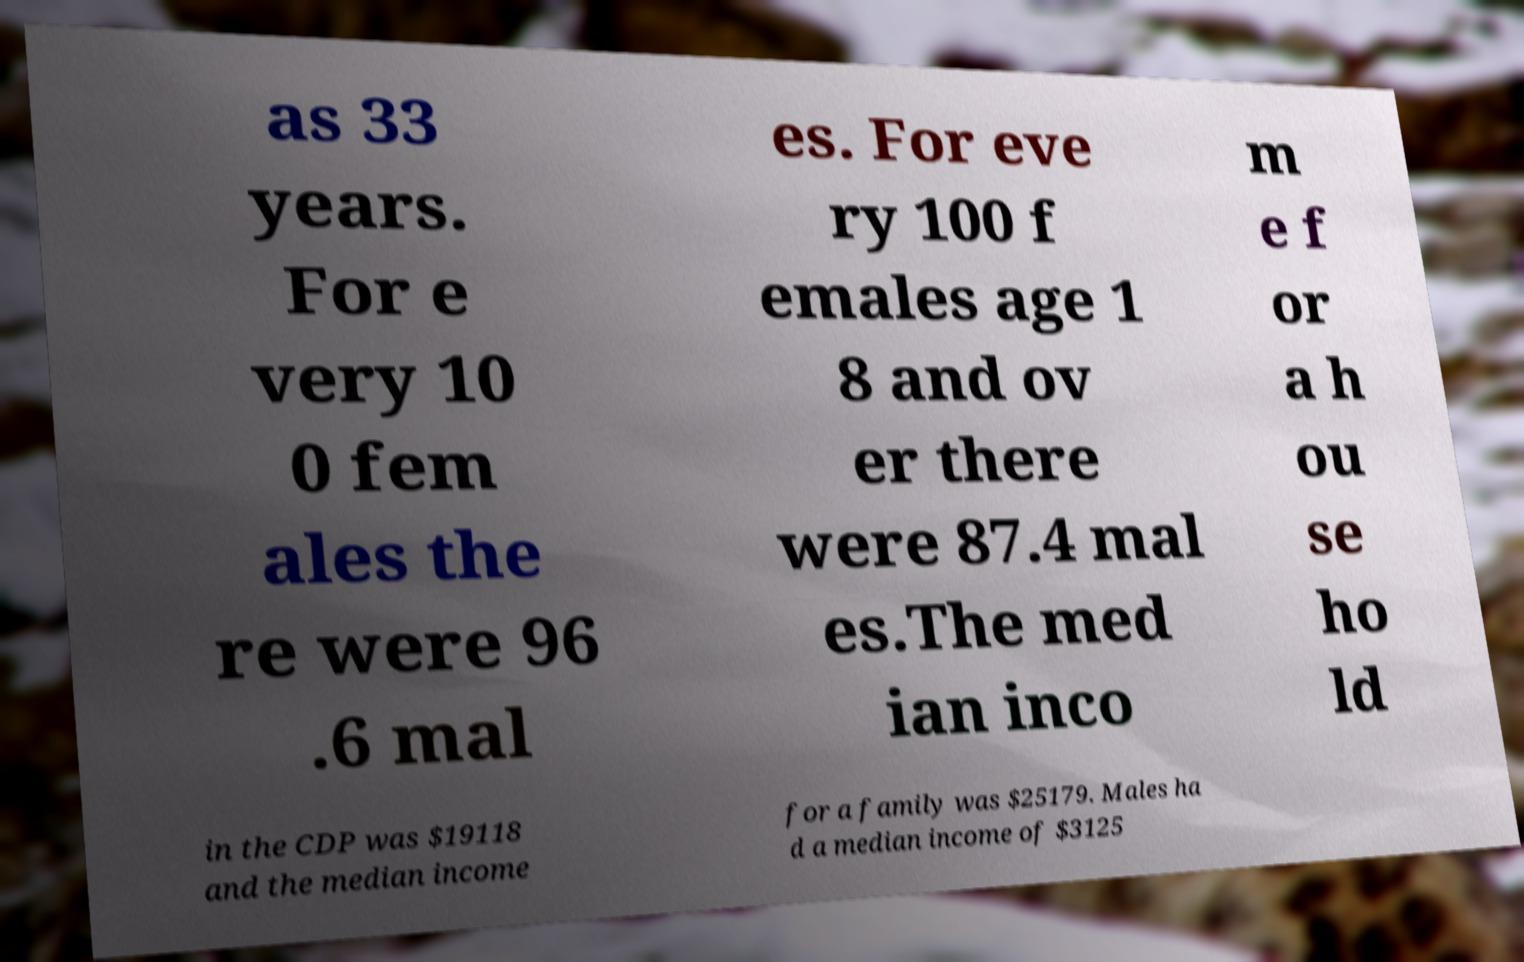Could you assist in decoding the text presented in this image and type it out clearly? as 33 years. For e very 10 0 fem ales the re were 96 .6 mal es. For eve ry 100 f emales age 1 8 and ov er there were 87.4 mal es.The med ian inco m e f or a h ou se ho ld in the CDP was $19118 and the median income for a family was $25179. Males ha d a median income of $3125 